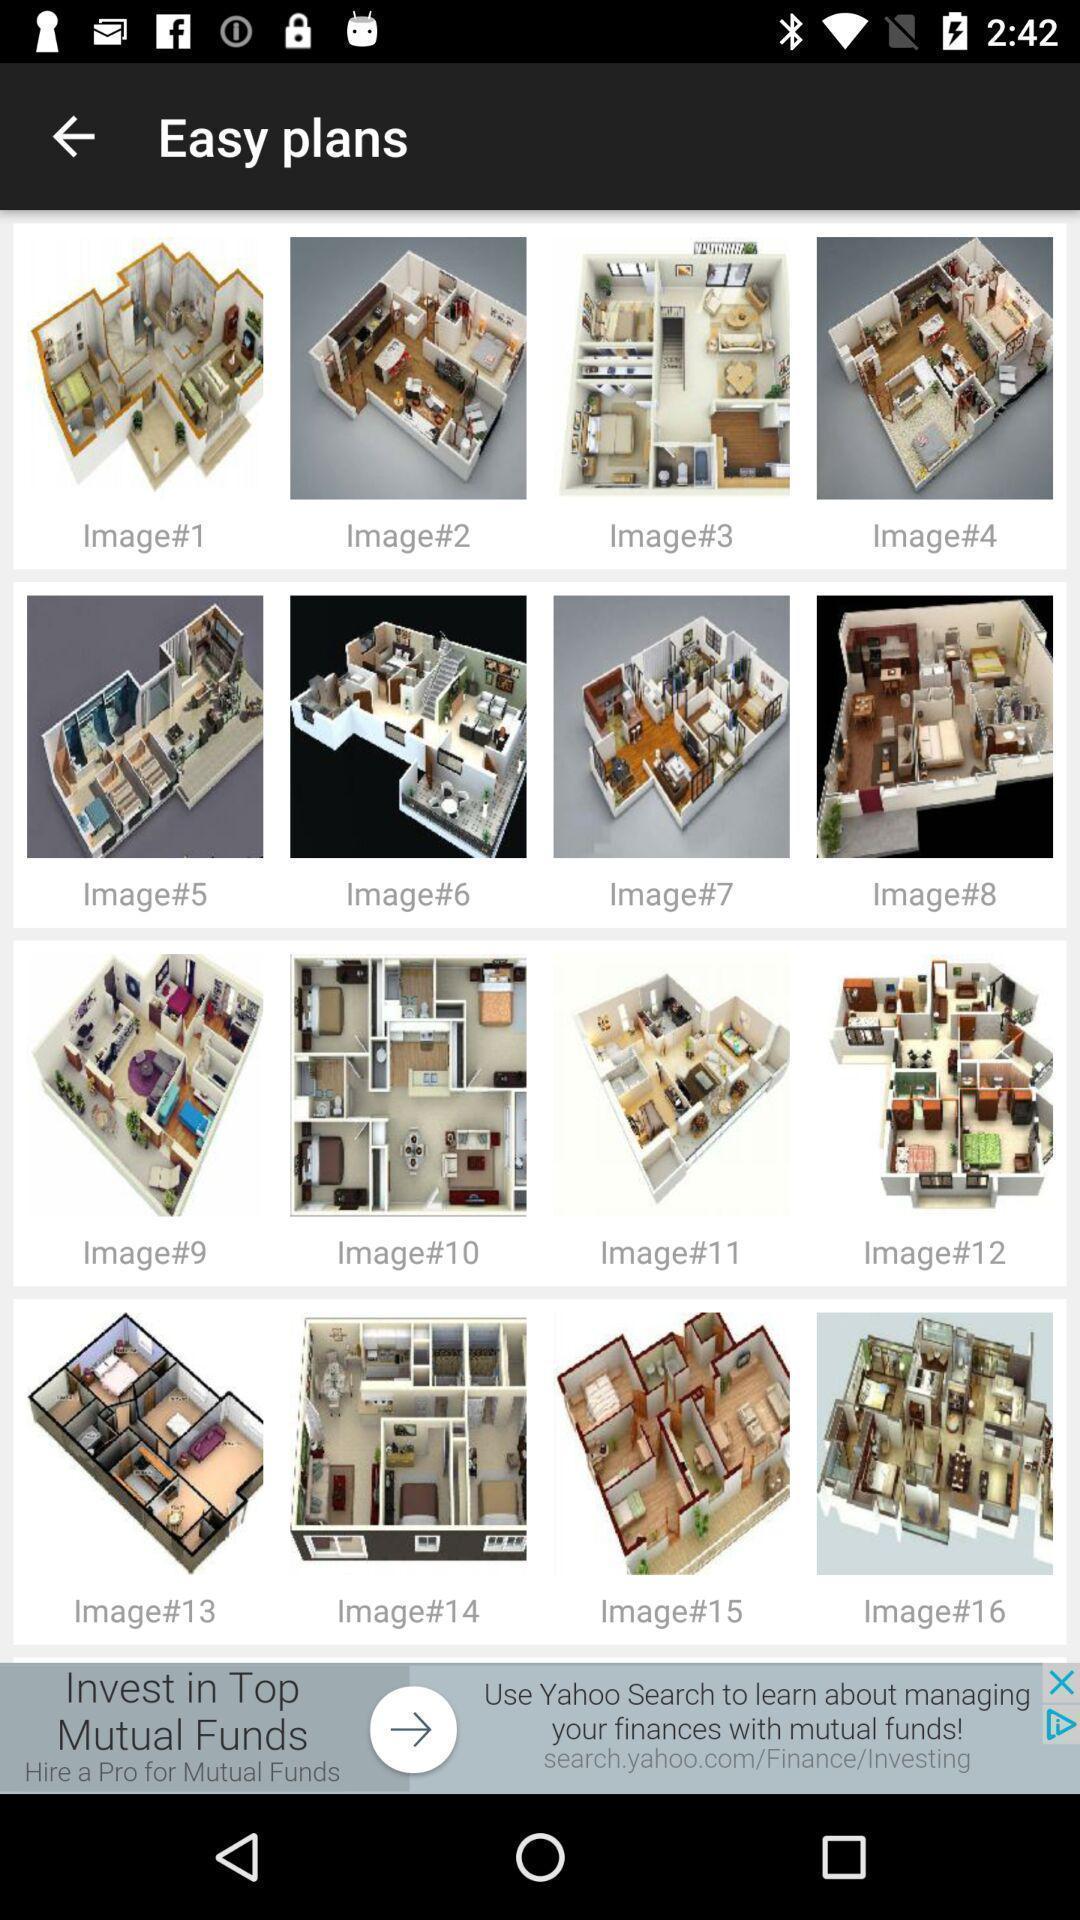Give me a narrative description of this picture. Various building plan images page displayed. 